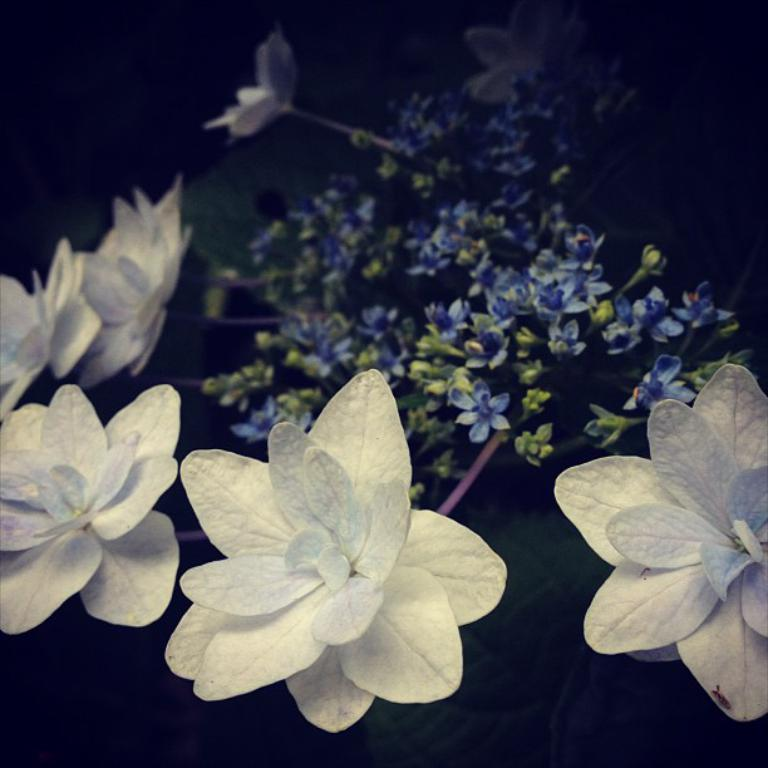What type of flowers are on the plant in the image? There are white flowers on the plant in the image. What color are the leaves on the plant? The leaves on the plant are green. What color is the background of the image? The background of the image is black. How many bananas are hanging from the plant in the image? There are no bananas present in the image; it features a plant with white flowers and green leaves. Can you see any mice hiding among the leaves in the image? There are no mice visible in the image; it only shows a plant with white flowers and green leaves against a black background. 